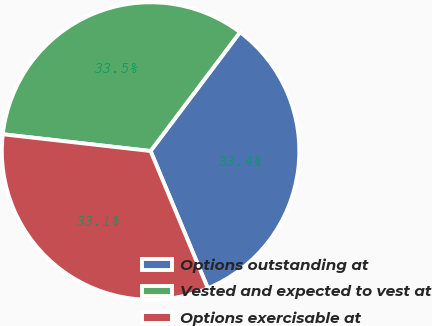<chart> <loc_0><loc_0><loc_500><loc_500><pie_chart><fcel>Options outstanding at<fcel>Vested and expected to vest at<fcel>Options exercisable at<nl><fcel>33.44%<fcel>33.47%<fcel>33.09%<nl></chart> 